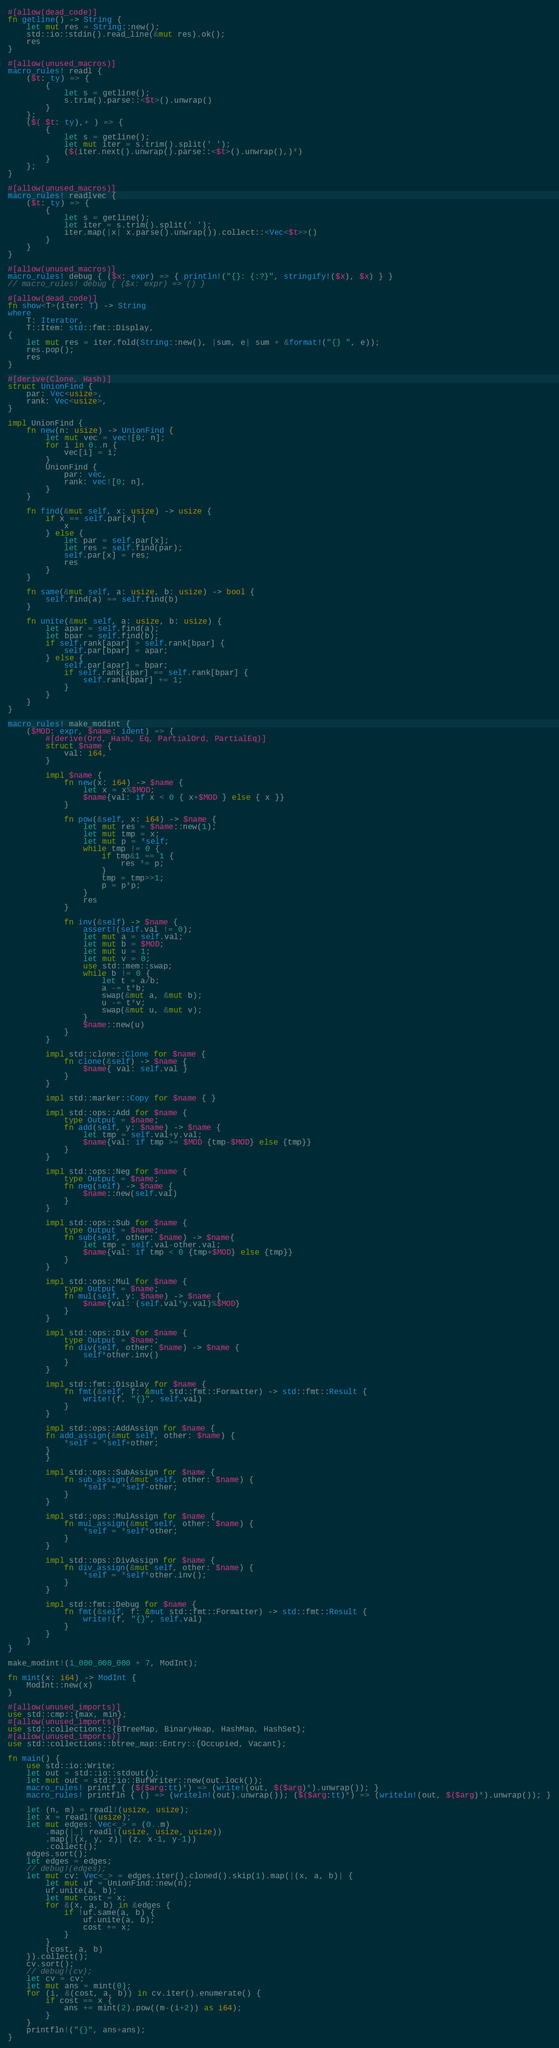<code> <loc_0><loc_0><loc_500><loc_500><_Rust_>#[allow(dead_code)]
fn getline() -> String {
    let mut res = String::new();
    std::io::stdin().read_line(&mut res).ok();
    res
}

#[allow(unused_macros)]
macro_rules! readl {
    ($t: ty) => {
        {
            let s = getline();
            s.trim().parse::<$t>().unwrap()
        }
    };
    ($( $t: ty),+ ) => {
        {
            let s = getline();
            let mut iter = s.trim().split(' ');
            ($(iter.next().unwrap().parse::<$t>().unwrap(),)*)
        }
    };
}

#[allow(unused_macros)]
macro_rules! readlvec {
    ($t: ty) => {
        {
            let s = getline();
            let iter = s.trim().split(' ');
            iter.map(|x| x.parse().unwrap()).collect::<Vec<$t>>()
        }
    }
}

#[allow(unused_macros)]
macro_rules! debug { ($x: expr) => { println!("{}: {:?}", stringify!($x), $x) } }
// macro_rules! debug { ($x: expr) => () }

#[allow(dead_code)]
fn show<T>(iter: T) -> String
where
    T: Iterator,
    T::Item: std::fmt::Display,
{
    let mut res = iter.fold(String::new(), |sum, e| sum + &format!("{} ", e));
    res.pop();
    res
}

#[derive(Clone, Hash)]
struct UnionFind {
    par: Vec<usize>,
    rank: Vec<usize>,
}

impl UnionFind {
    fn new(n: usize) -> UnionFind {
        let mut vec = vec![0; n];
        for i in 0..n {
            vec[i] = i;
        }
        UnionFind {
            par: vec,
            rank: vec![0; n],
        }
    }

    fn find(&mut self, x: usize) -> usize {
        if x == self.par[x] {
            x
        } else {
            let par = self.par[x];
            let res = self.find(par);
            self.par[x] = res;
            res
        }
    }

    fn same(&mut self, a: usize, b: usize) -> bool {
        self.find(a) == self.find(b)
    }

    fn unite(&mut self, a: usize, b: usize) {
        let apar = self.find(a);
        let bpar = self.find(b);
        if self.rank[apar] > self.rank[bpar] {
            self.par[bpar] = apar;
        } else {
            self.par[apar] = bpar;
            if self.rank[apar] == self.rank[bpar] {
                self.rank[bpar] += 1;
            }
        }
    }
}

macro_rules! make_modint {
    ($MOD: expr, $name: ident) => {
        #[derive(Ord, Hash, Eq, PartialOrd, PartialEq)]
        struct $name {
            val: i64,
        }

        impl $name {
            fn new(x: i64) -> $name {
                let x = x%$MOD;
                $name{val: if x < 0 { x+$MOD } else { x }}
            }

            fn pow(&self, x: i64) -> $name {
                let mut res = $name::new(1);
                let mut tmp = x;
                let mut p = *self;
                while tmp != 0 {
                    if tmp&1 == 1 {
                        res *= p;
                    }
                    tmp = tmp>>1;
                    p = p*p;
                }
                res
            }

            fn inv(&self) -> $name {
                assert!(self.val != 0);
                let mut a = self.val;
                let mut b = $MOD;
                let mut u = 1;
                let mut v = 0;
                use std::mem::swap;
                while b != 0 {
                    let t = a/b;
                    a -= t*b;
                    swap(&mut a, &mut b);
                    u -= t*v;
                    swap(&mut u, &mut v);
                }
                $name::new(u)
            }
        }

        impl std::clone::Clone for $name {
            fn clone(&self) -> $name {
                $name{ val: self.val }
            }
        }

        impl std::marker::Copy for $name { }

        impl std::ops::Add for $name {
            type Output = $name;
            fn add(self, y: $name) -> $name {
                let tmp = self.val+y.val;
                $name{val: if tmp >= $MOD {tmp-$MOD} else {tmp}}
            }
        }

        impl std::ops::Neg for $name {
            type Output = $name;
            fn neg(self) -> $name {
                $name::new(self.val)
            }
        }

        impl std::ops::Sub for $name {
            type Output = $name;
            fn sub(self, other: $name) -> $name{
                let tmp = self.val-other.val;
                $name{val: if tmp < 0 {tmp+$MOD} else {tmp}}
            }
        }

        impl std::ops::Mul for $name {
            type Output = $name;
            fn mul(self, y: $name) -> $name {
                $name{val: (self.val*y.val)%$MOD}
            }
        }

        impl std::ops::Div for $name {
            type Output = $name;
            fn div(self, other: $name) -> $name {
                self*other.inv()
            }
        }

        impl std::fmt::Display for $name {
            fn fmt(&self, f: &mut std::fmt::Formatter) -> std::fmt::Result {
                write!(f, "{}", self.val)
            }
        }

        impl std::ops::AddAssign for $name {
        fn add_assign(&mut self, other: $name) {
            *self = *self+other;
        }
        }

        impl std::ops::SubAssign for $name {
            fn sub_assign(&mut self, other: $name) {
                *self = *self-other;
            }
        }

        impl std::ops::MulAssign for $name {
            fn mul_assign(&mut self, other: $name) {
                *self = *self*other;
            }
        }

        impl std::ops::DivAssign for $name {
            fn div_assign(&mut self, other: $name) {
                *self = *self*other.inv();
            }
        }

        impl std::fmt::Debug for $name {
            fn fmt(&self, f: &mut std::fmt::Formatter) -> std::fmt::Result {
                write!(f, "{}", self.val)
            }
        }
    }
}

make_modint!(1_000_000_000 + 7, ModInt);

fn mint(x: i64) -> ModInt {
    ModInt::new(x)
}

#[allow(unused_imports)]
use std::cmp::{max, min};
#[allow(unused_imports)]
use std::collections::{BTreeMap, BinaryHeap, HashMap, HashSet};
#[allow(unused_imports)]
use std::collections::btree_map::Entry::{Occupied, Vacant};

fn main() {
    use std::io::Write;
    let out = std::io::stdout();
    let mut out = std::io::BufWriter::new(out.lock());
    macro_rules! printf { ($($arg:tt)*) => (write!(out, $($arg)*).unwrap()); }
    macro_rules! printfln { () => (writeln!(out).unwrap()); ($($arg:tt)*) => (writeln!(out, $($arg)*).unwrap()); }

    let (n, m) = readl!(usize, usize);
    let x = readl!(usize);
    let mut edges: Vec<_> = (0..m)
        .map(|_| readl!(usize, usize, usize))
        .map(|(x, y, z)| (z, x-1, y-1))
        .collect();
    edges.sort();
    let edges = edges;
    // debug!(edges);
    let mut cv: Vec<_> = edges.iter().cloned().skip(1).map(|(x, a, b)| {
        let mut uf = UnionFind::new(n);
        uf.unite(a, b);
        let mut cost = x;
        for &(x, a, b) in &edges {
            if !uf.same(a, b) {
                uf.unite(a, b);
                cost += x;
            }
        }
        (cost, a, b)
    }).collect();
    cv.sort();
    // debug!(cv);
    let cv = cv;
    let mut ans = mint(0);
    for (i, &(cost, a, b)) in cv.iter().enumerate() {
        if cost == x {
            ans += mint(2).pow((m-(i+2)) as i64);
        }
    }
    printfln!("{}", ans+ans);
}
</code> 